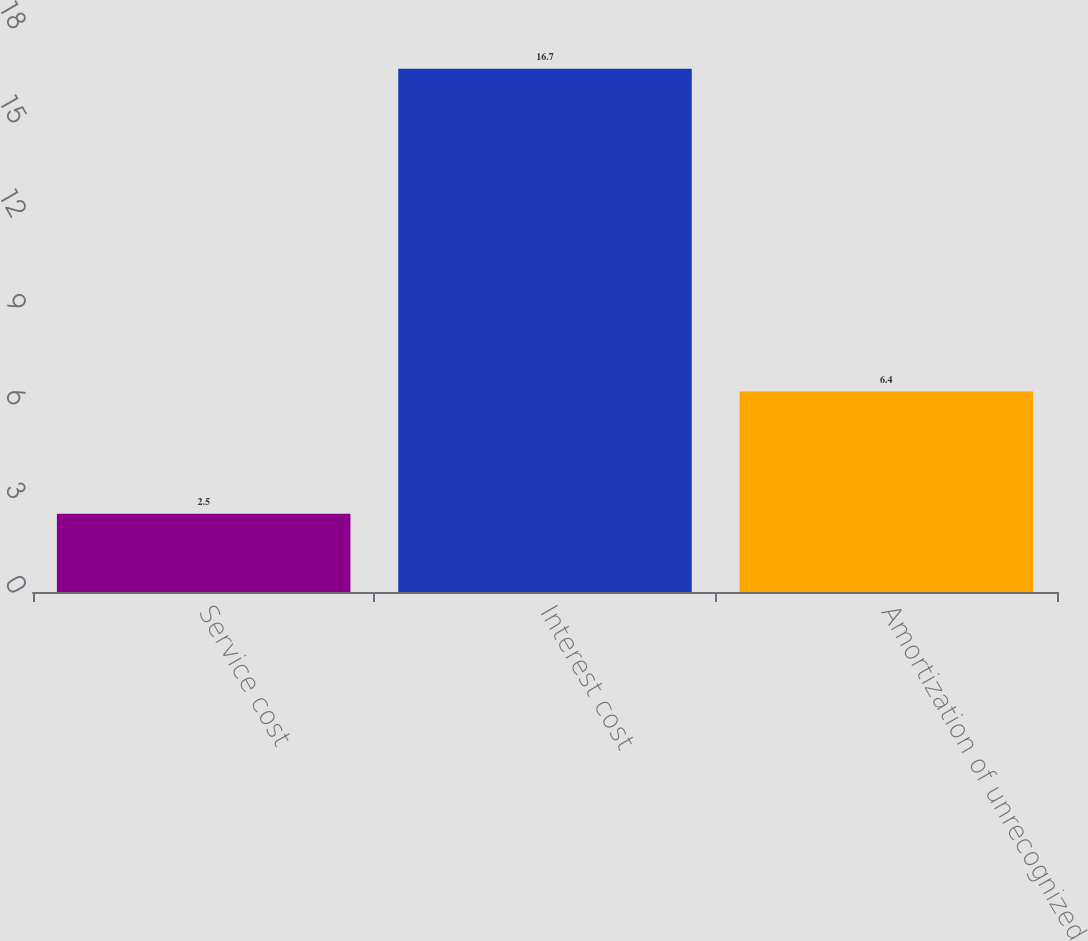Convert chart to OTSL. <chart><loc_0><loc_0><loc_500><loc_500><bar_chart><fcel>Service cost<fcel>Interest cost<fcel>Amortization of unrecognized<nl><fcel>2.5<fcel>16.7<fcel>6.4<nl></chart> 